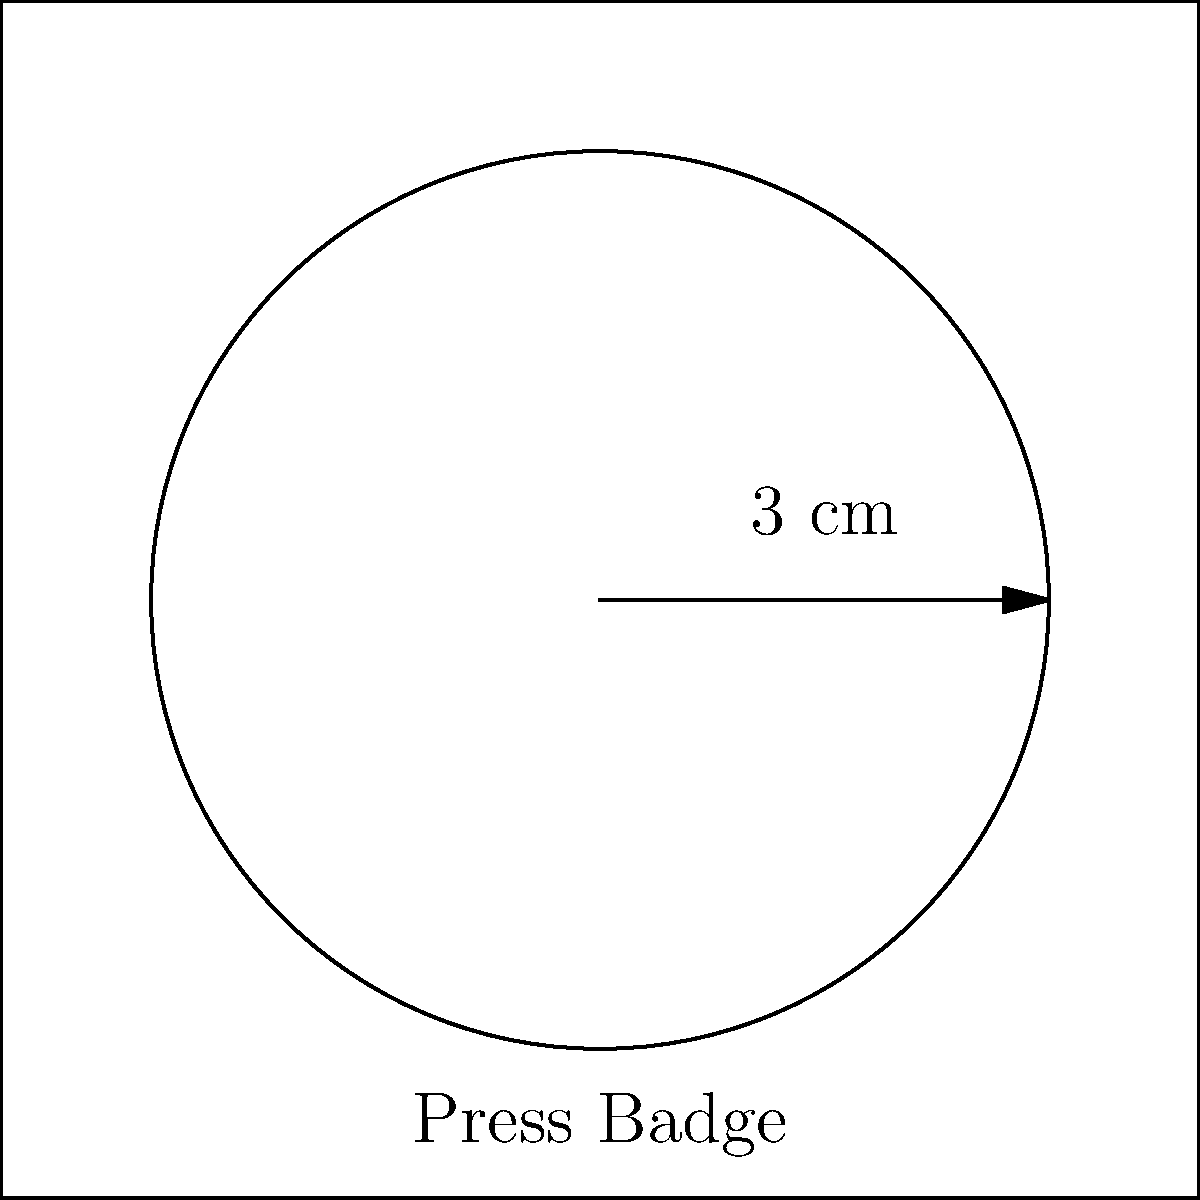As a new journalism student, you've been given a circular press badge for your first assignment. The badge has a radius of 3 cm. What is the perimeter of the press badge? To find the perimeter of a circular press badge, we need to calculate its circumference. The formula for the circumference of a circle is:

$$C = 2\pi r$$

Where:
$C$ = circumference
$\pi$ = pi (approximately 3.14159)
$r$ = radius

Given:
Radius ($r$) = 3 cm

Step 1: Substitute the values into the formula
$$C = 2\pi (3)$$

Step 2: Simplify
$$C = 6\pi$$

Step 3: Calculate the final value (rounded to two decimal places)
$$C \approx 6 * 3.14159 \approx 18.85 \text{ cm}$$

Therefore, the perimeter of the circular press badge is approximately 18.85 cm.
Answer: $18.85 \text{ cm}$ 